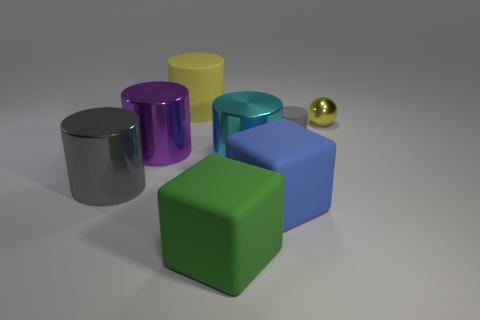Is the material of the tiny gray object the same as the yellow object that is on the left side of the blue thing?
Your answer should be very brief. Yes. There is a big object that is the same color as the tiny shiny ball; what shape is it?
Offer a very short reply. Cylinder. How many blue blocks have the same size as the cyan shiny cylinder?
Make the answer very short. 1. Are there fewer yellow rubber cylinders that are right of the tiny gray matte cylinder than big cyan things?
Your answer should be very brief. Yes. There is a big cyan metal cylinder; how many large blue rubber things are right of it?
Offer a terse response. 1. What is the size of the thing that is in front of the large object that is right of the big cylinder on the right side of the big rubber cylinder?
Provide a succinct answer. Large. Is the shape of the yellow shiny object the same as the rubber object behind the tiny yellow metal sphere?
Provide a succinct answer. No. What size is the green cube that is made of the same material as the large yellow cylinder?
Your answer should be compact. Large. What material is the gray thing that is right of the matte cylinder that is on the left side of the gray cylinder that is on the right side of the yellow rubber cylinder?
Keep it short and to the point. Rubber. What number of rubber things are either small yellow things or big gray things?
Offer a very short reply. 0. 